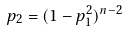Convert formula to latex. <formula><loc_0><loc_0><loc_500><loc_500>p _ { 2 } = ( 1 - p _ { 1 } ^ { 2 } ) ^ { n - 2 }</formula> 